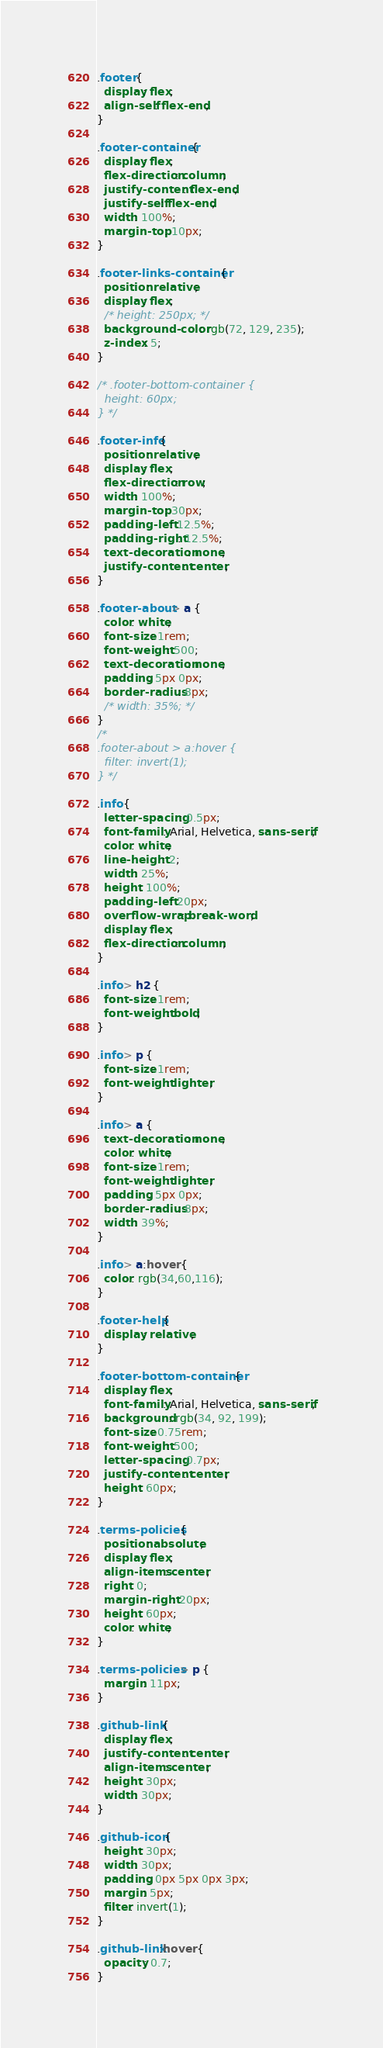<code> <loc_0><loc_0><loc_500><loc_500><_CSS_>.footer {
  display: flex;
  align-self: flex-end;
}

.footer-container {
  display: flex;
  flex-direction: column;
  justify-content: flex-end;
  justify-self: flex-end;
  width: 100%;
  margin-top: 10px;
}

.footer-links-container {
  position: relative;
  display: flex;
  /* height: 250px; */
  background-color: rgb(72, 129, 235);
  z-index: 5;
}

/* .footer-bottom-container {
  height: 60px;
} */

.footer-info {
  position: relative;
  display: flex;
  flex-direction: row;
  width: 100%;
  margin-top: 30px;
  padding-left: 12.5%;
  padding-right: 12.5%;
  text-decoration: none;
  justify-content: center;
}

.footer-about > a {
  color: white;
  font-size: 1rem;
  font-weight: 500;
  text-decoration: none;
  padding: 5px 0px;
  border-radius: 8px;
  /* width: 35%; */
}
/* 
.footer-about > a:hover {
  filter: invert(1);
} */

.info {
  letter-spacing: 0.5px;
  font-family: Arial, Helvetica, sans-serif;
  color: white;
  line-height: 2;
  width: 25%;
  height: 100%;
  padding-left: 20px;
  overflow-wrap: break-word;
  display: flex;
  flex-direction: column;
}

.info > h2 {
  font-size: 1rem;
  font-weight: bold;
}

.info > p {
  font-size: 1rem;
  font-weight: lighter;
}

.info > a {
  text-decoration: none;
  color: white;
  font-size: 1rem;
  font-weight: lighter;
  padding: 5px 0px;
  border-radius: 8px;
  width: 39%;
}

.info > a:hover {
  color: rgb(34,60,116);
}

.footer-help {
  display: relative;
}

.footer-bottom-container {
  display: flex;
  font-family: Arial, Helvetica, sans-serif;
  background: rgb(34, 92, 199);
  font-size: 0.75rem;
  font-weight: 500;
  letter-spacing: 0.7px;
  justify-content: center;
  height: 60px;
}

.terms-policies {
  position: absolute;
  display: flex;
  align-items: center;
  right: 0;
  margin-right: 20px;
  height: 60px;
  color: white;
}

.terms-policies > p {
  margin: 11px;
}

.github-link {
  display: flex;
  justify-content: center;
  align-items: center;
  height: 30px;
  width: 30px;
}

.github-icon {
  height: 30px;
  width: 30px;
  padding: 0px 5px 0px 3px;
  margin: 5px;
  filter: invert(1);
}

.github-link:hover {
  opacity: 0.7;
}
</code> 